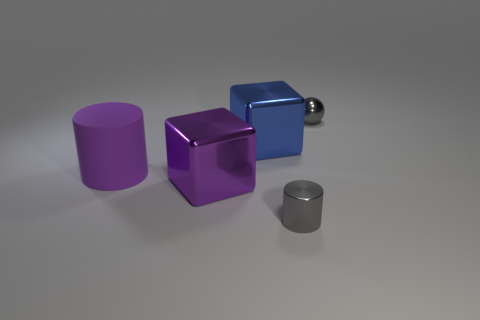Is there a tiny thing behind the large metal thing that is in front of the shiny cube that is behind the large rubber thing?
Your answer should be compact. Yes. There is another shiny object that is the same shape as the purple metallic thing; what color is it?
Keep it short and to the point. Blue. How many green objects are either metal balls or rubber cylinders?
Your answer should be very brief. 0. There is a cylinder that is left of the cylinder in front of the large purple cylinder; what is its material?
Make the answer very short. Rubber. Is the large purple metal object the same shape as the large purple matte object?
Provide a short and direct response. No. The other cube that is the same size as the purple metal cube is what color?
Your answer should be very brief. Blue. Is there a shiny cylinder that has the same color as the sphere?
Provide a succinct answer. Yes. Is there a yellow matte cylinder?
Give a very brief answer. No. Is the material of the tiny thing that is in front of the large blue metal thing the same as the purple cylinder?
Keep it short and to the point. No. What is the size of the metallic cube that is the same color as the large matte cylinder?
Provide a succinct answer. Large. 